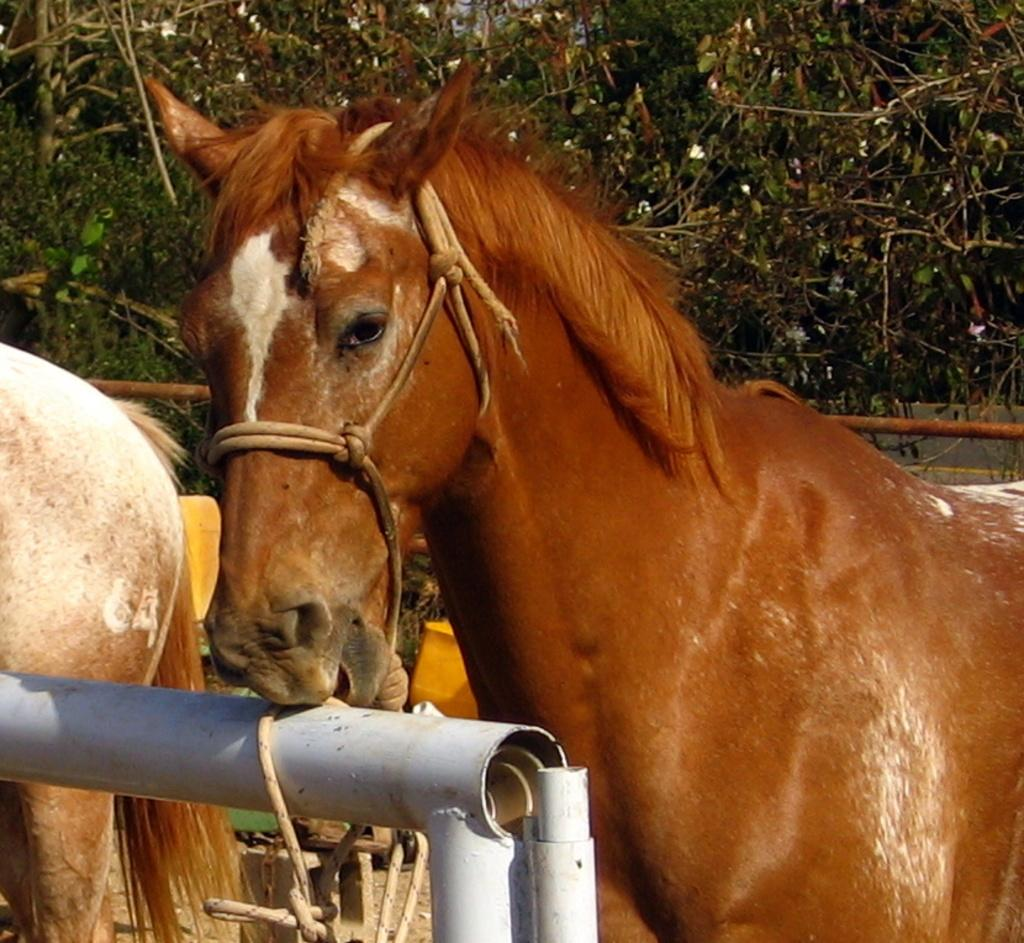What animals are in the center of the image? There are horses in the center of the image. What is located in the front of the image? There is a pole in the front of the image, and it is white in color. What can be seen in the background of the image? There are trees in the background of the image. What is the income of the cow in the image? There is no cow present in the image, so it is not possible to determine its income. 